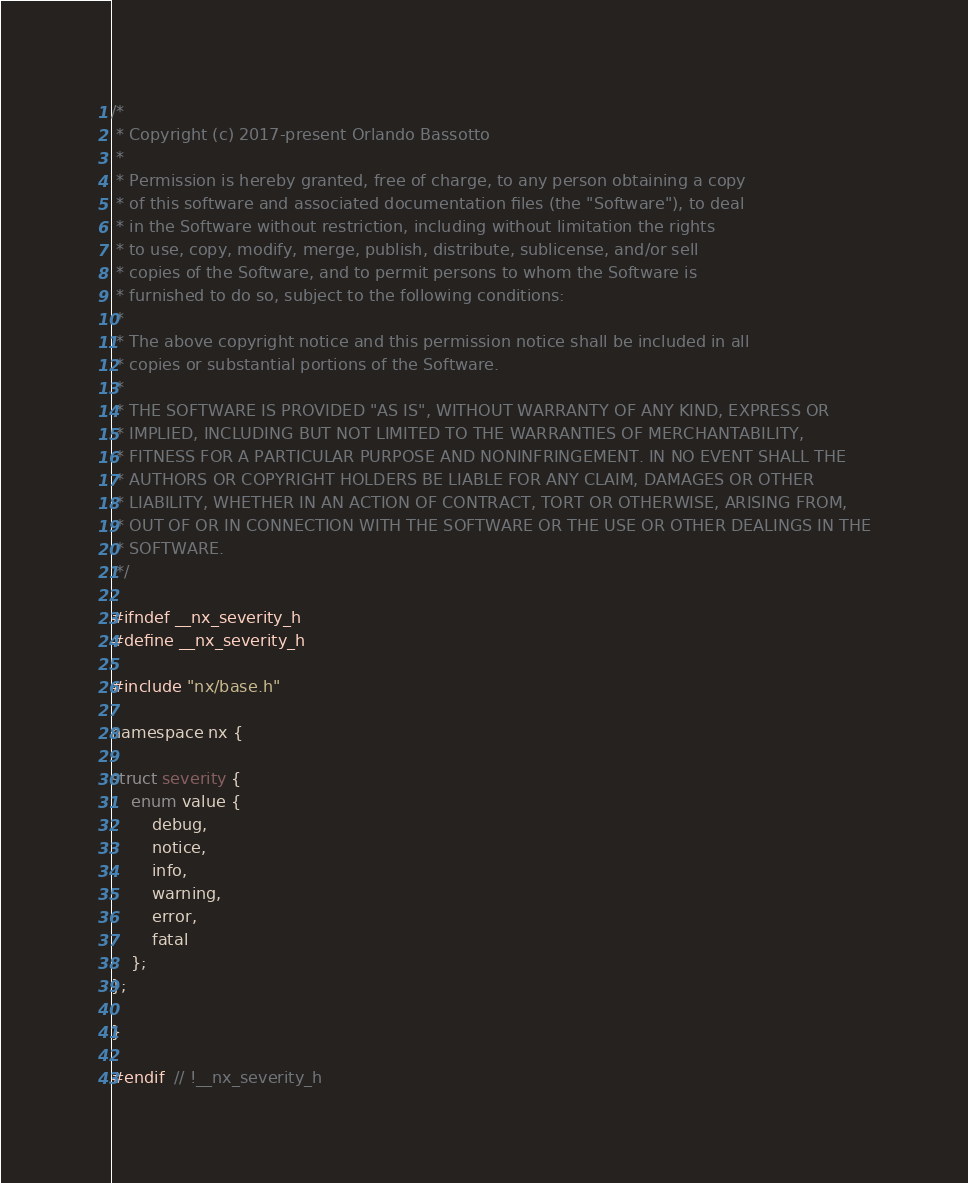<code> <loc_0><loc_0><loc_500><loc_500><_C_>/*
 * Copyright (c) 2017-present Orlando Bassotto
 *
 * Permission is hereby granted, free of charge, to any person obtaining a copy
 * of this software and associated documentation files (the "Software"), to deal
 * in the Software without restriction, including without limitation the rights
 * to use, copy, modify, merge, publish, distribute, sublicense, and/or sell
 * copies of the Software, and to permit persons to whom the Software is
 * furnished to do so, subject to the following conditions:
 *
 * The above copyright notice and this permission notice shall be included in all
 * copies or substantial portions of the Software.
 *
 * THE SOFTWARE IS PROVIDED "AS IS", WITHOUT WARRANTY OF ANY KIND, EXPRESS OR
 * IMPLIED, INCLUDING BUT NOT LIMITED TO THE WARRANTIES OF MERCHANTABILITY,
 * FITNESS FOR A PARTICULAR PURPOSE AND NONINFRINGEMENT. IN NO EVENT SHALL THE
 * AUTHORS OR COPYRIGHT HOLDERS BE LIABLE FOR ANY CLAIM, DAMAGES OR OTHER
 * LIABILITY, WHETHER IN AN ACTION OF CONTRACT, TORT OR OTHERWISE, ARISING FROM,
 * OUT OF OR IN CONNECTION WITH THE SOFTWARE OR THE USE OR OTHER DEALINGS IN THE
 * SOFTWARE.
 */

#ifndef __nx_severity_h
#define __nx_severity_h

#include "nx/base.h"

namespace nx {

struct severity {
    enum value {
        debug,
        notice,
        info,
        warning,
        error,
        fatal
    };
};

}

#endif  // !__nx_severity_h
</code> 